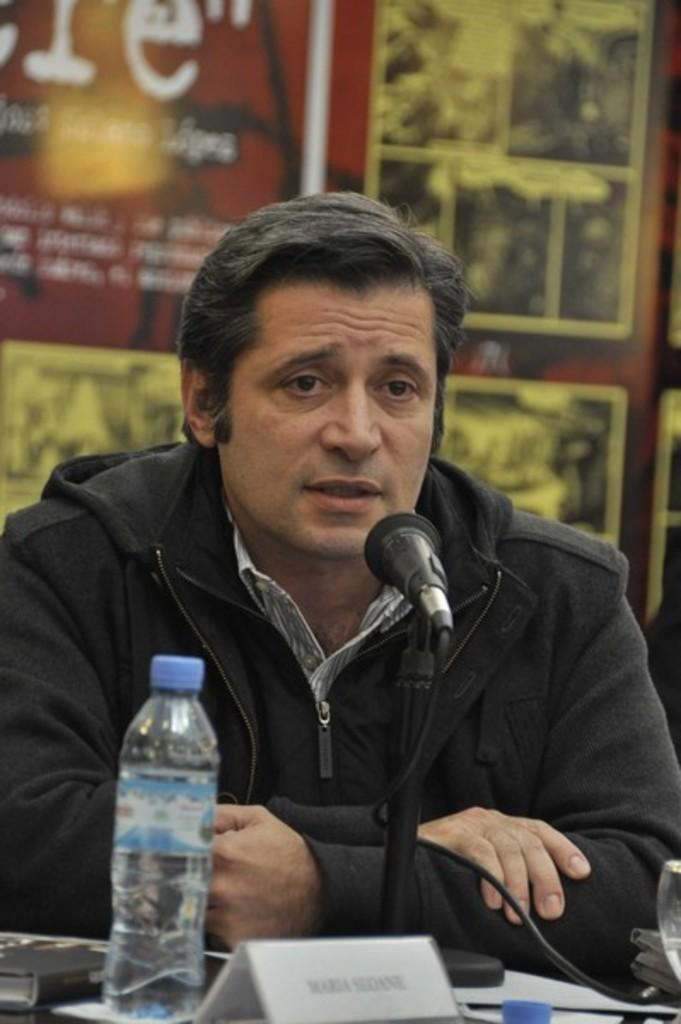What is the person in the image doing? The person is sitting in front of the table. What objects are on the table? There is a bottle, a book, and a mic on the table. What can be seen in the background of the image? There is a board in the background. What color is the curtain behind the person in the image? There is no curtain present in the image. How many shops can be seen in the background of the image? There are no shops visible in the image; it only shows a board in the background. 